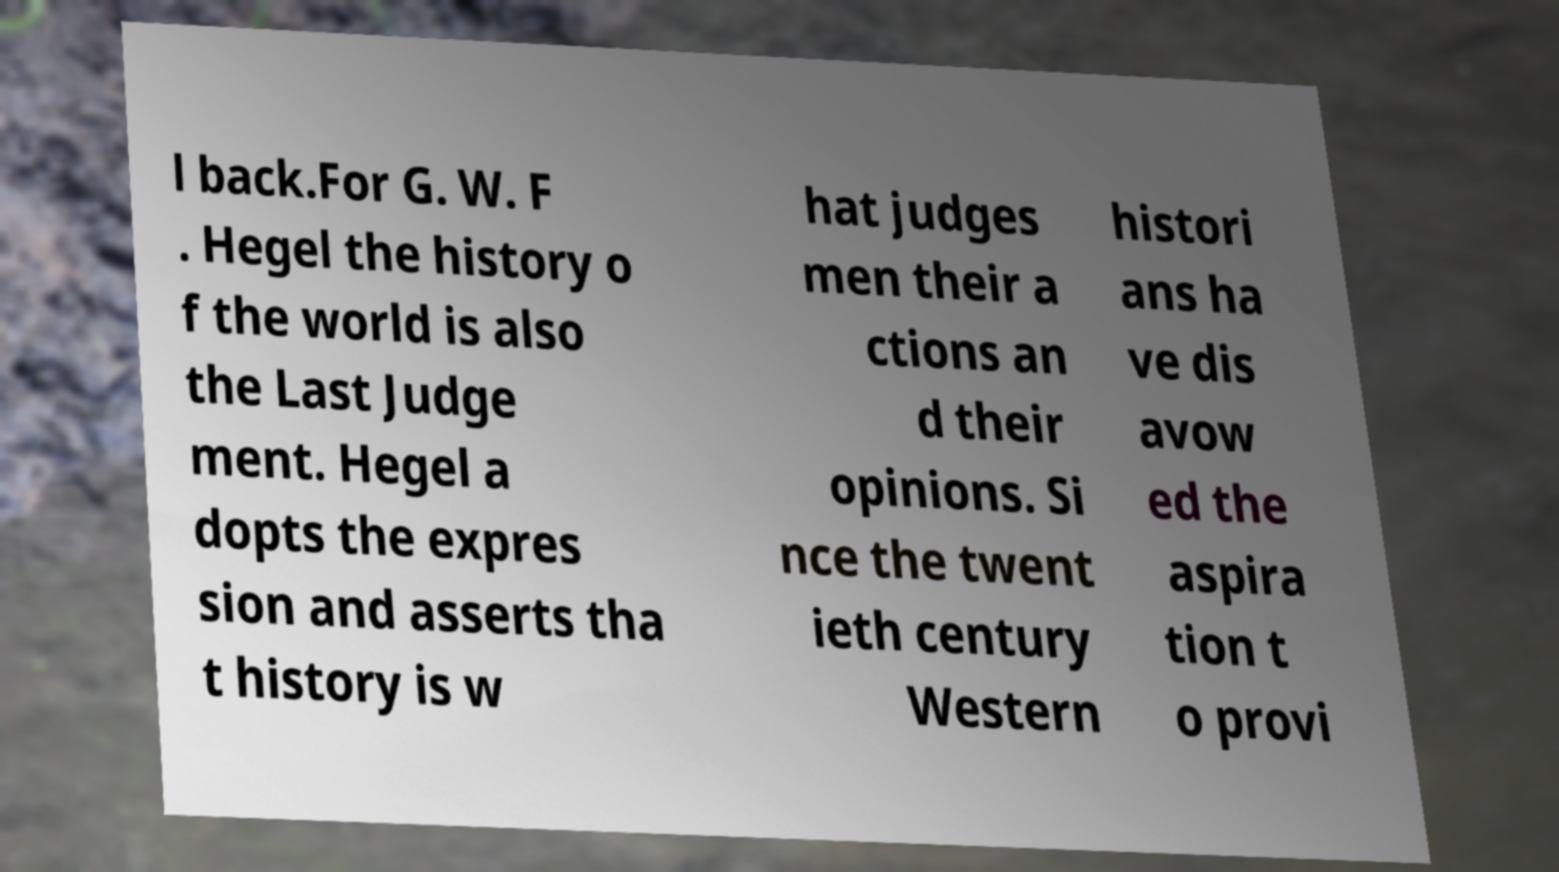Can you read and provide the text displayed in the image?This photo seems to have some interesting text. Can you extract and type it out for me? l back.For G. W. F . Hegel the history o f the world is also the Last Judge ment. Hegel a dopts the expres sion and asserts tha t history is w hat judges men their a ctions an d their opinions. Si nce the twent ieth century Western histori ans ha ve dis avow ed the aspira tion t o provi 